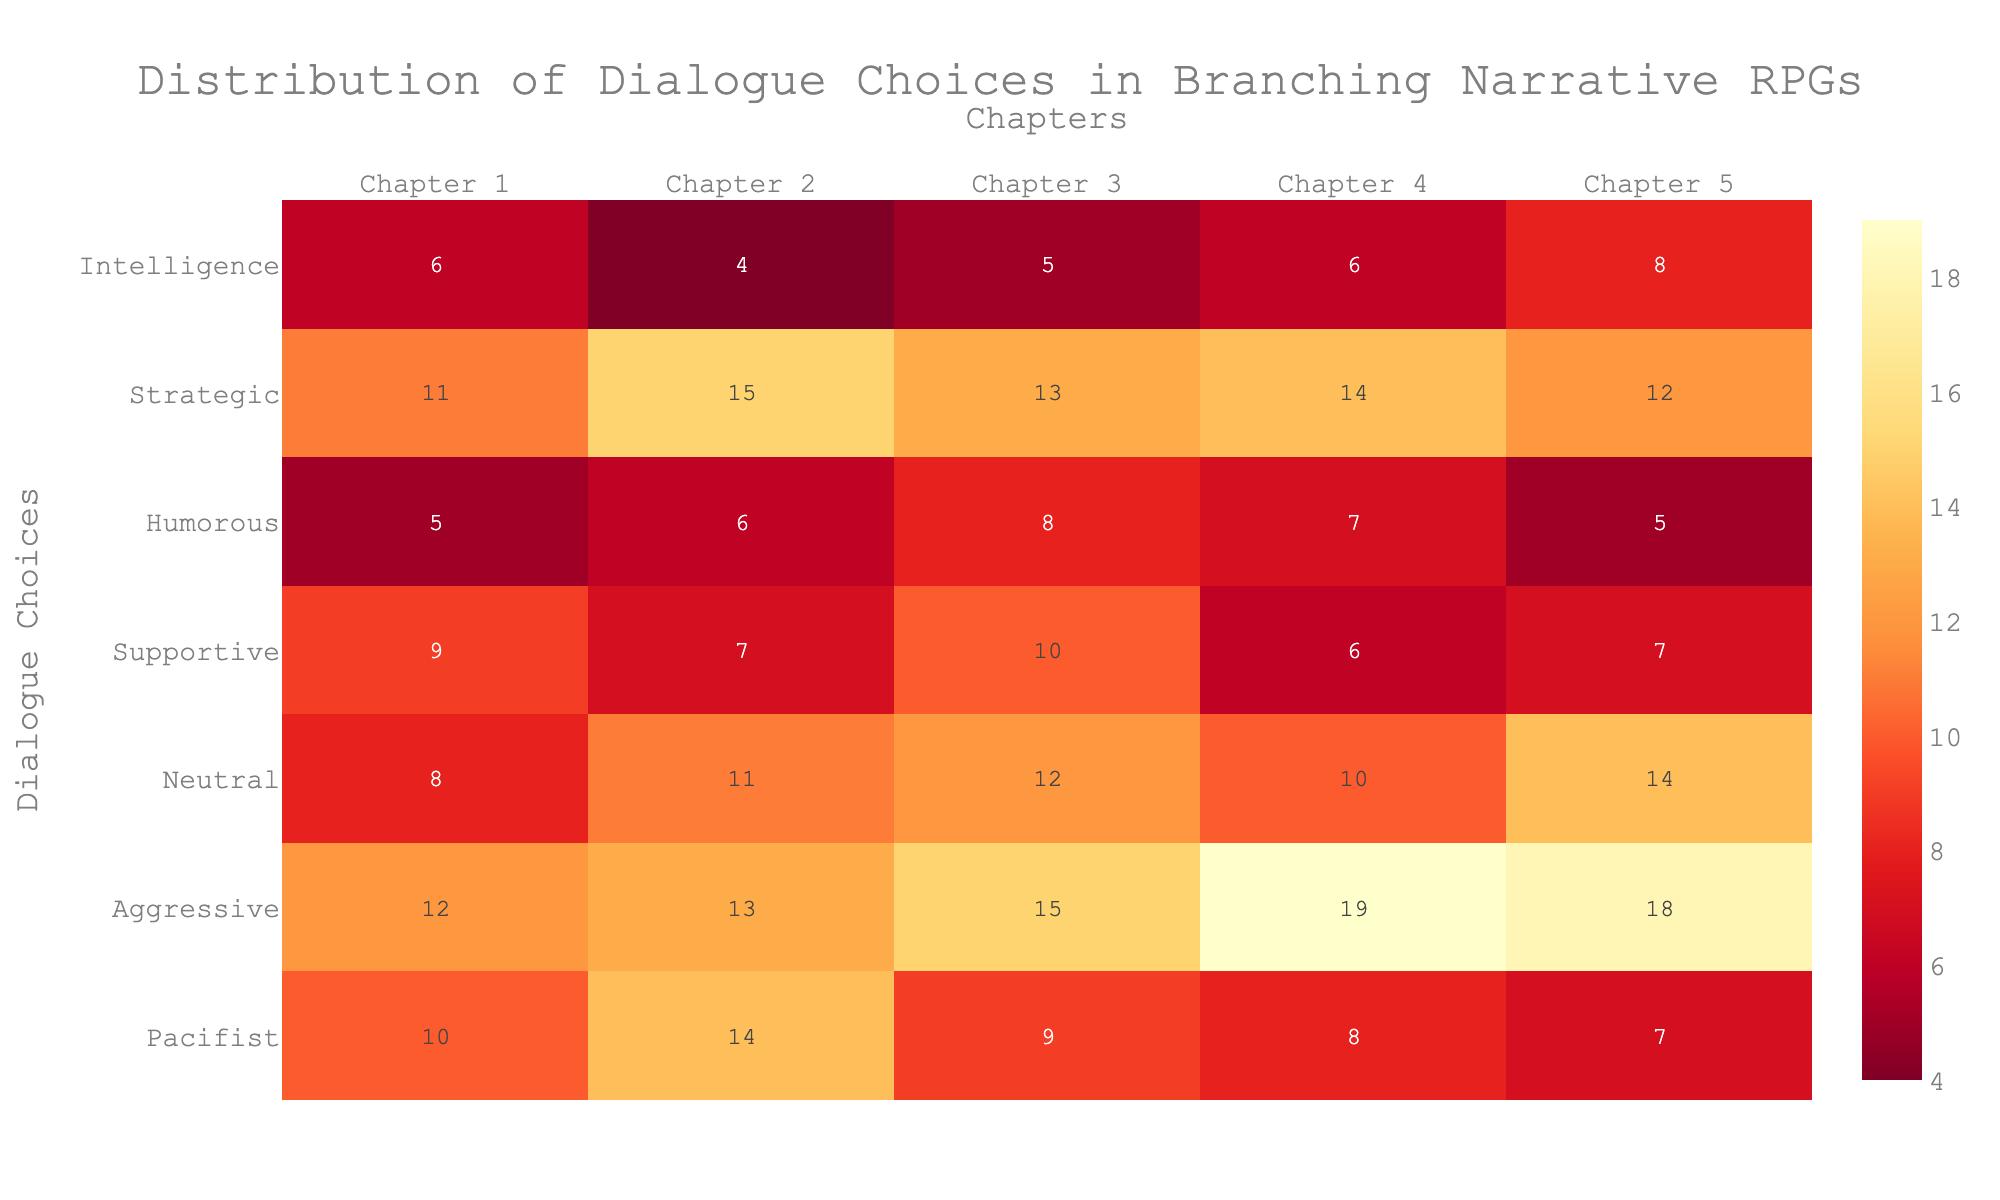What is the title of the heatmap? The title is usually displayed prominently at the top of the heatmap. By looking at the top-center area of the heatmap, you can read it.
Answer: Distribution of Dialogue Choices in Branching Narrative RPGs Which chapter has the highest number of Aggressive choices? Locate the "Aggressive" row and scan horizontally to find the highest value. The highest value in this row is 19, found under Chapter 4.
Answer: Chapter 4 How many total choices are available in Chapter 3? Add the values in Column "Chapter 3": Pacifist (9), Aggressive (15), Neutral (12), Supportive (10), Humorous (8), Strategic (13), Intelligence (5). The sum is 9 + 15 + 12 + 10 + 8 + 13 + 5 = 72.
Answer: 72 Which dialogue choice has the least total choices across all chapters? Scan the "Total Choices" column to find the smallest number. The smallest number is 29 for "Intelligence".
Answer: Intelligence What is the average number of Neutral choices per chapter? Take the total number of Neutral choices (55) and divide by the number of chapters (5). 55 / 5 = 11.
Answer: 11 Which chapters have more than 10 Supportive choices? Look at the "Supportive" row and identify chapters with values greater than 10. Only Chapter 3 has a value (10) that meets the criteria.
Answer: None Compare the number of Strategic and Supportive choices in Chapter 2. Which one is higher? Look at the values for Strategic and Supportive in Chapter 2. Strategic has 15, and Supportive has 7. 15 > 7, so Strategic has more choices.
Answer: Strategic What is the sum of Pacifist and Humorous choices in Chapter 1? Add the values for Pacifist (10) and Humorous (5) in Chapter 1. The sum is 10 + 5 = 15.
Answer: 15 Which dialogue choice shows the most consistent number of choices across all chapters? Look for the row where the values are the most similar across the chapters. The "Strategic" row shows values of 11, 15, 13, 14, and 12, which are relatively close to each other.
Answer: Strategic 